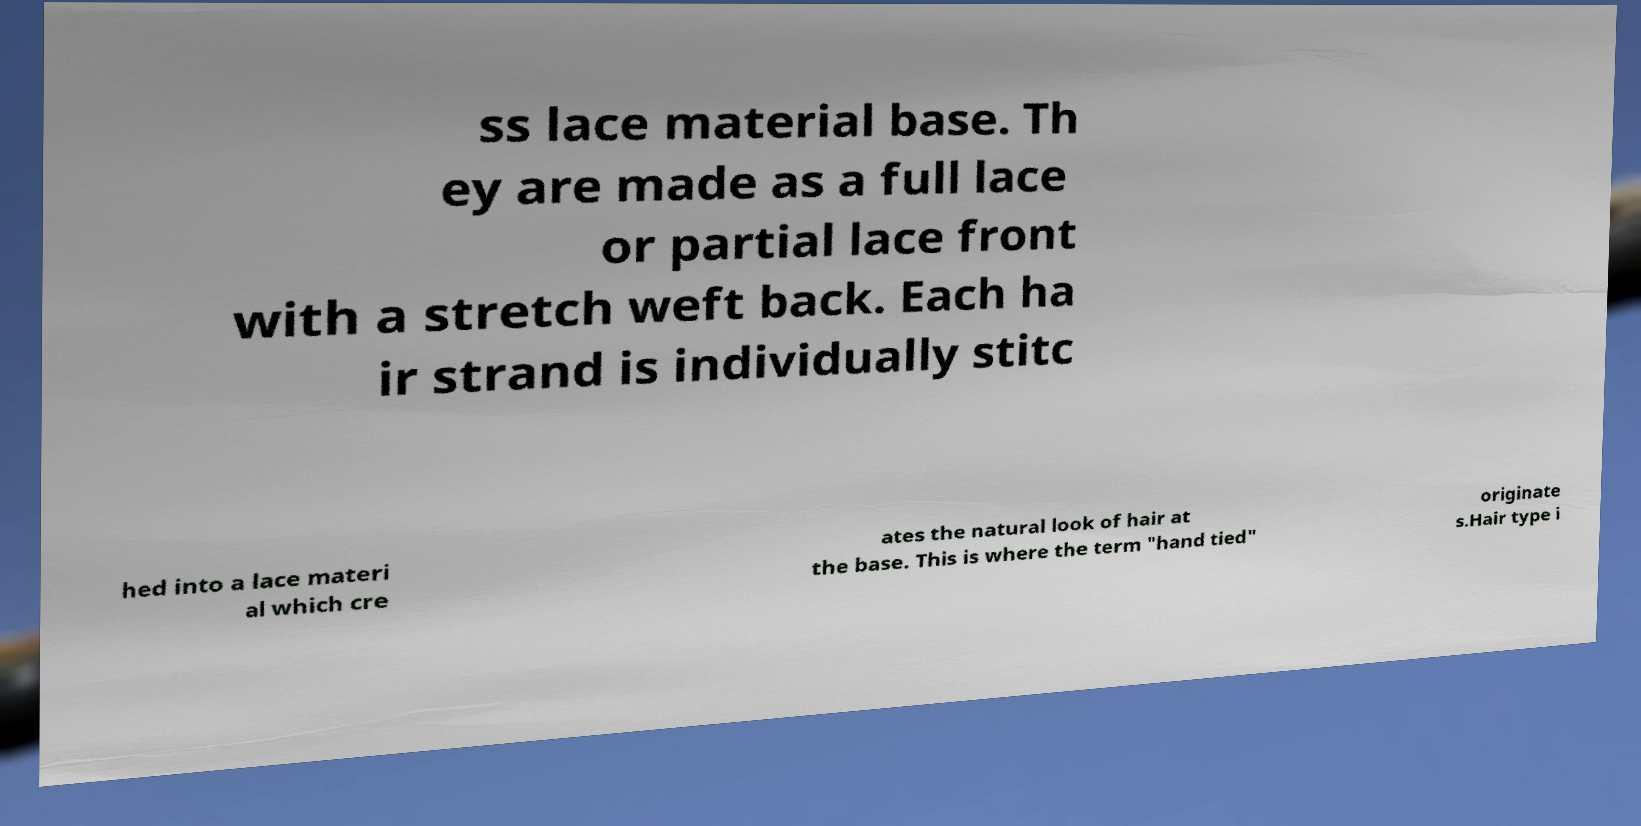For documentation purposes, I need the text within this image transcribed. Could you provide that? ss lace material base. Th ey are made as a full lace or partial lace front with a stretch weft back. Each ha ir strand is individually stitc hed into a lace materi al which cre ates the natural look of hair at the base. This is where the term "hand tied" originate s.Hair type i 